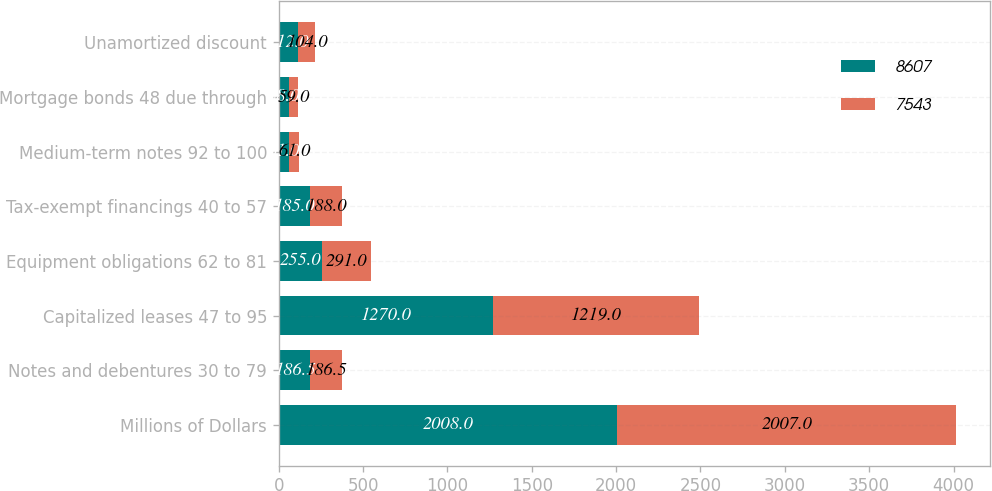Convert chart. <chart><loc_0><loc_0><loc_500><loc_500><stacked_bar_chart><ecel><fcel>Millions of Dollars<fcel>Notes and debentures 30 to 79<fcel>Capitalized leases 47 to 95<fcel>Equipment obligations 62 to 81<fcel>Tax-exempt financings 40 to 57<fcel>Medium-term notes 92 to 100<fcel>Mortgage bonds 48 due through<fcel>Unamortized discount<nl><fcel>8607<fcel>2008<fcel>186.5<fcel>1270<fcel>255<fcel>185<fcel>61<fcel>58<fcel>112<nl><fcel>7543<fcel>2007<fcel>186.5<fcel>1219<fcel>291<fcel>188<fcel>61<fcel>59<fcel>104<nl></chart> 